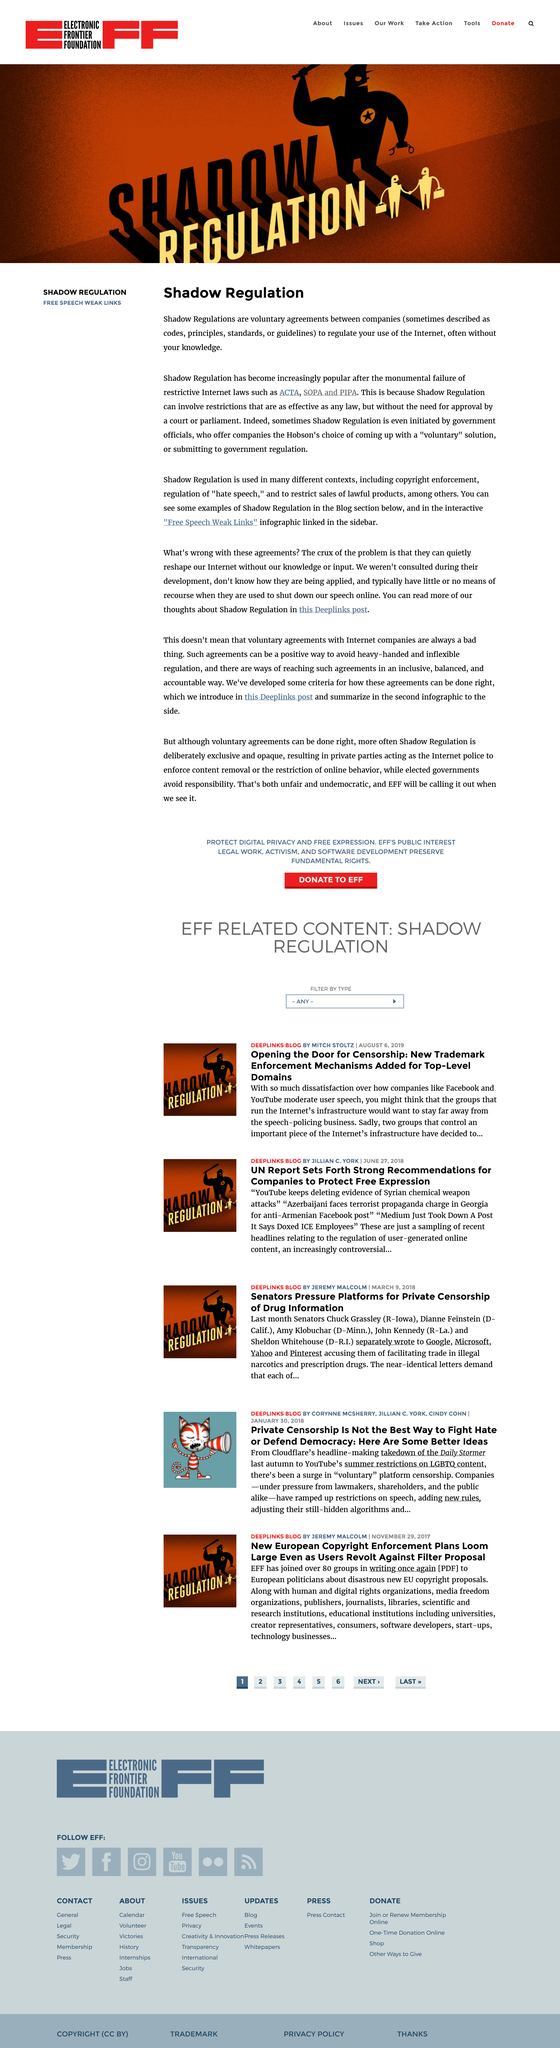Give some essential details in this illustration. Government officials sometimes initiate Shadow Regulations, which are rules and guidelines that are not officially recognized but still have significant impact on businesses and individuals. Yes, Shadow Regulations are voluntary agreements. Yes, shadow regulation is an example of a free speech weak link. 